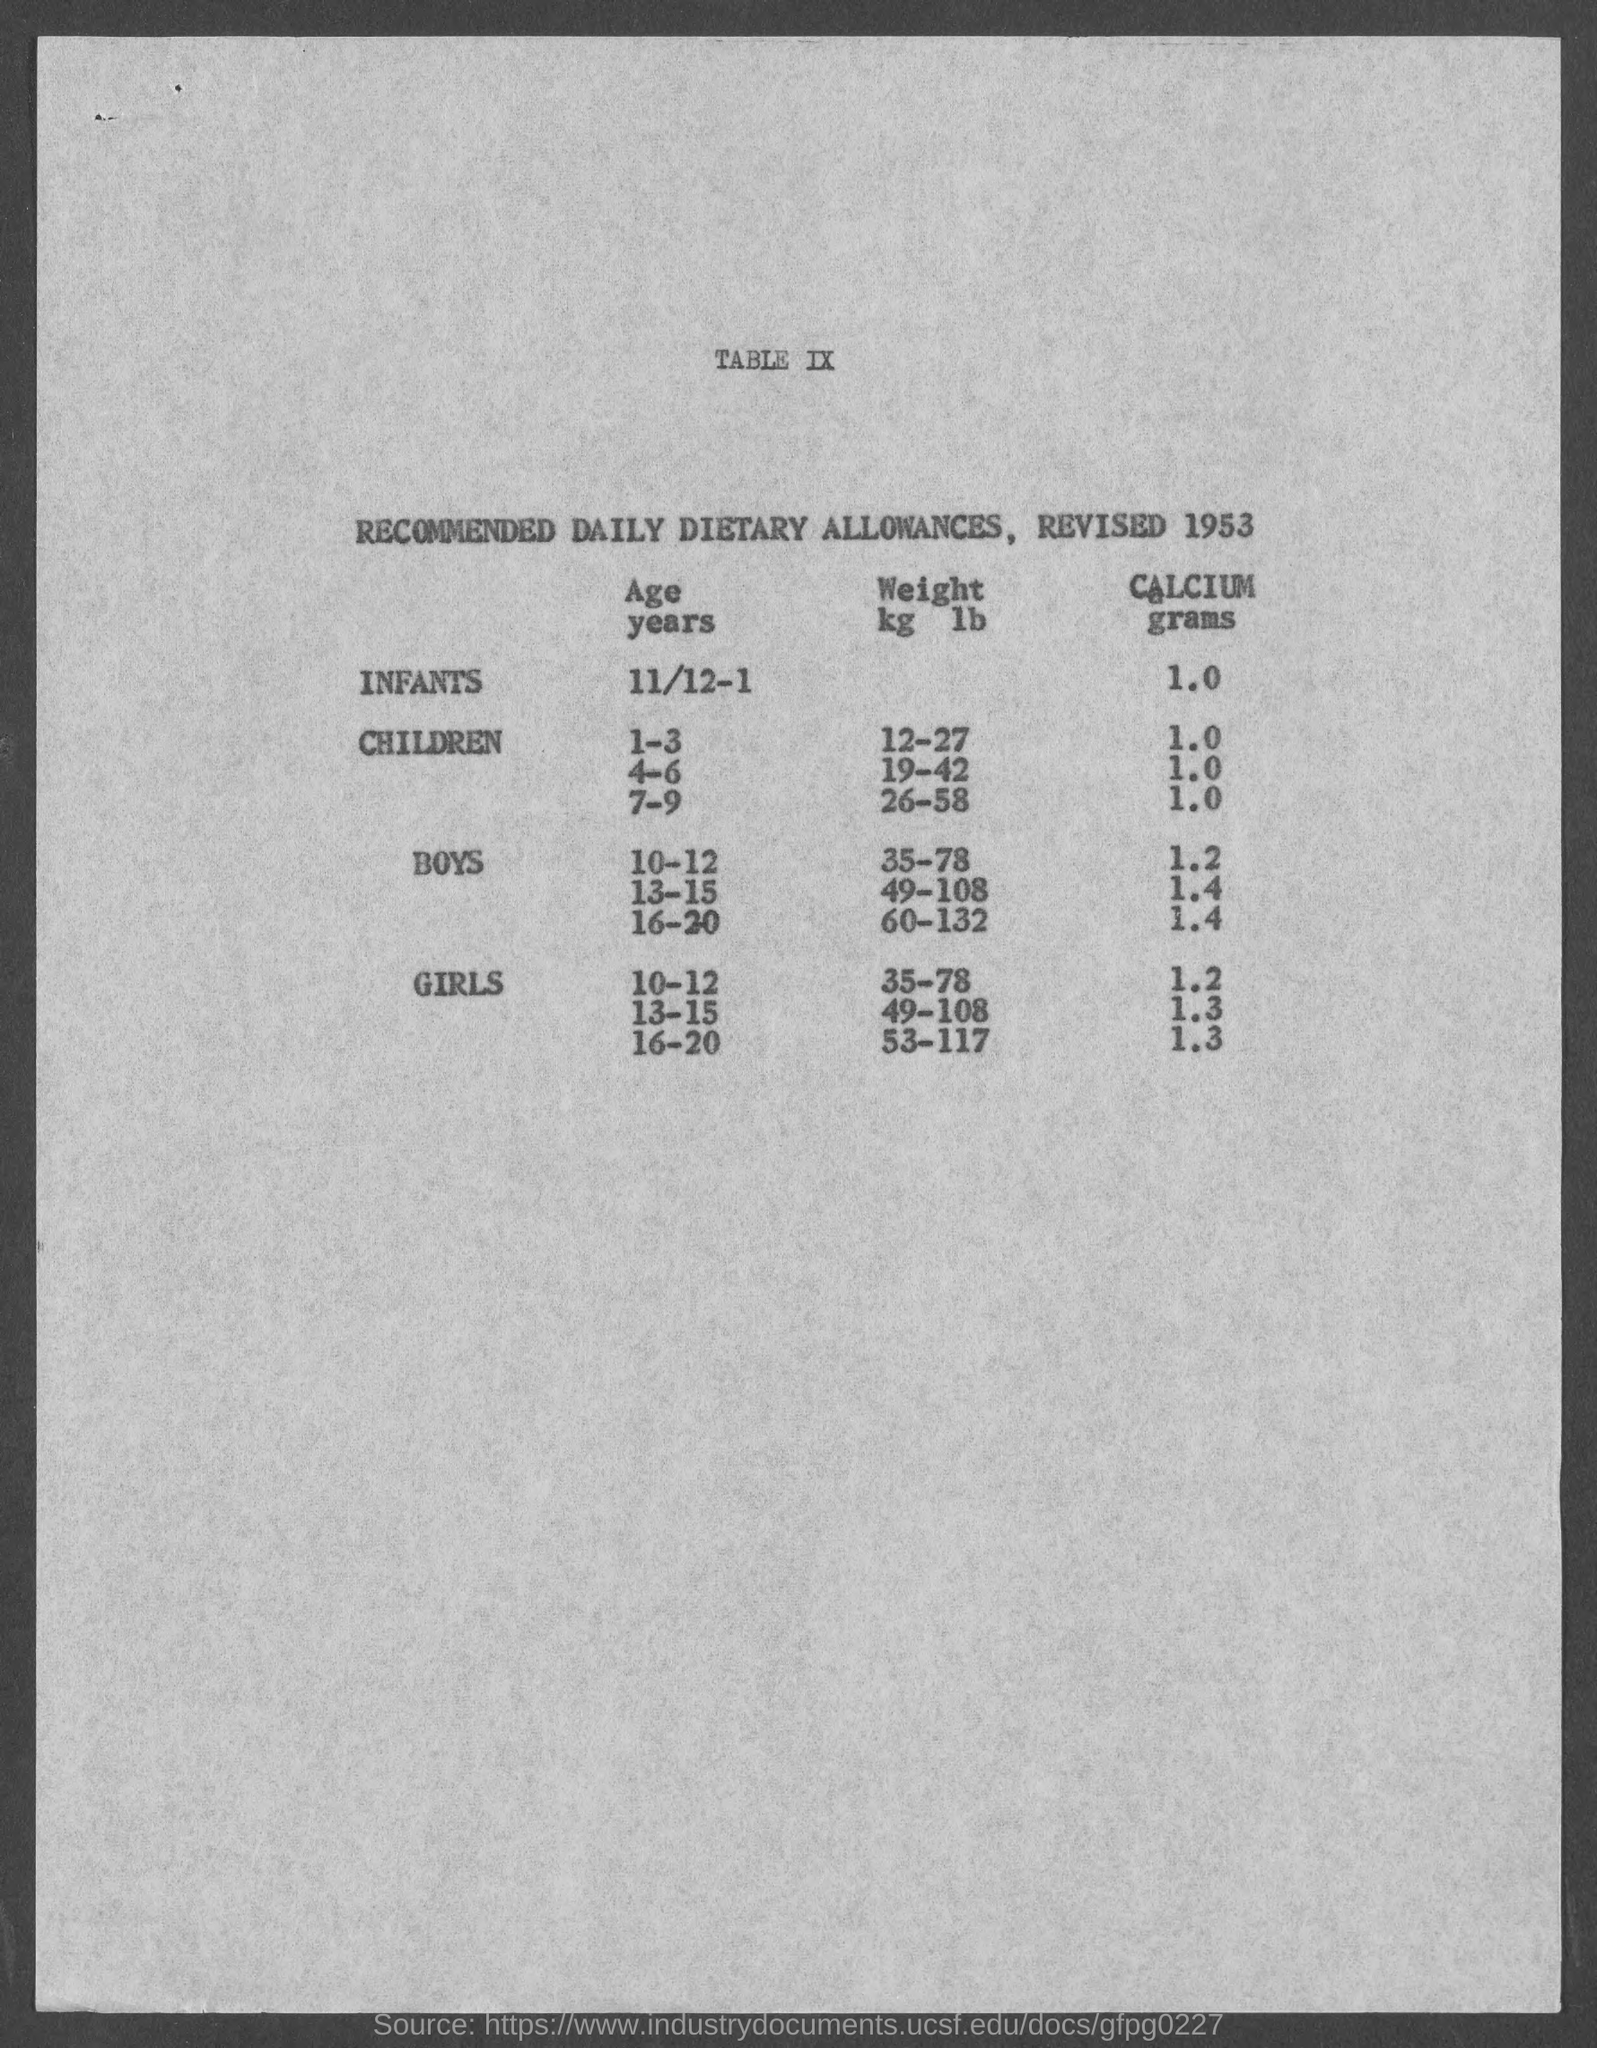What is the recommnded weight(kg/lb) for the children in the age group 1-3?
Make the answer very short. 12-27. What is the recommnded weight(kg/lb) for boys in the age group 10-12?
Offer a very short reply. 35-78. What is the recommended grams of calcium for  girls in the age group 10-12?
Provide a succinct answer. 1.2. What is the recommended grams of calcium for boys  in the age group 16-20?
Your answer should be very brief. 1.4. What is the recommnded weight(kg/lb) for children in the age group 7-9?
Ensure brevity in your answer.  26-58. 